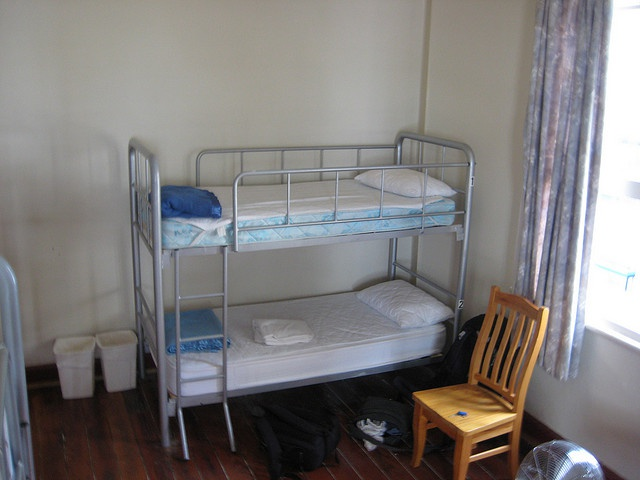Describe the objects in this image and their specific colors. I can see bed in gray and darkgray tones and chair in gray, maroon, olive, and black tones in this image. 